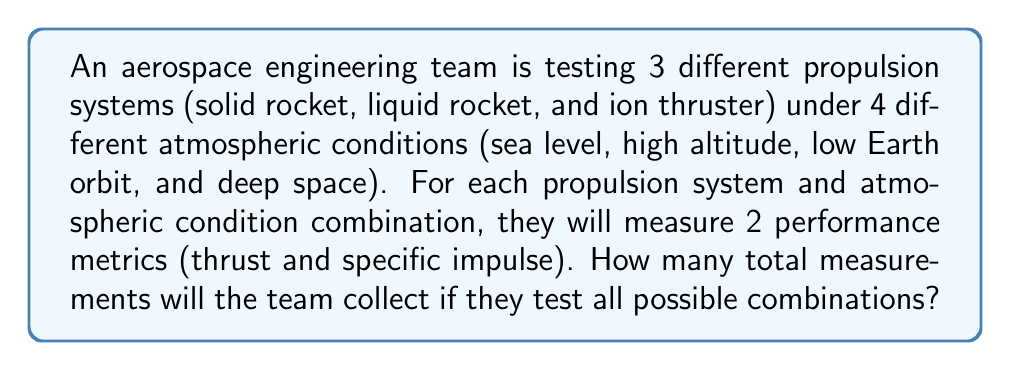Help me with this question. Let's break this down step-by-step:

1) First, we need to identify the independent variables:
   - Number of propulsion systems: 3
   - Number of atmospheric conditions: 4
   - Number of performance metrics: 2

2) This is a multiplication principle problem. We need to multiply the number of options for each variable to get the total number of combinations.

3) For each propulsion system:
   - It will be tested under all 4 atmospheric conditions
   - For each condition, both performance metrics will be measured

4) We can represent this mathematically as:

   $$ \text{Total measurements} = \text{Propulsion systems} \times \text{Atmospheric conditions} \times \text{Performance metrics} $$

5) Substituting the values:

   $$ \text{Total measurements} = 3 \times 4 \times 2 $$

6) Calculating the result:

   $$ \text{Total measurements} = 24 $$

Therefore, the team will collect 24 total measurements.
Answer: 24 measurements 